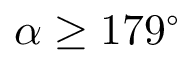<formula> <loc_0><loc_0><loc_500><loc_500>\alpha \geq 1 7 9 ^ { \circ }</formula> 